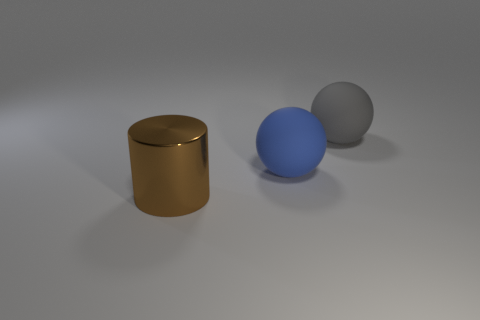Add 3 green cubes. How many objects exist? 6 Subtract all cylinders. How many objects are left? 2 Add 2 matte objects. How many matte objects exist? 4 Subtract 0 purple cubes. How many objects are left? 3 Subtract all large balls. Subtract all brown objects. How many objects are left? 0 Add 2 matte spheres. How many matte spheres are left? 4 